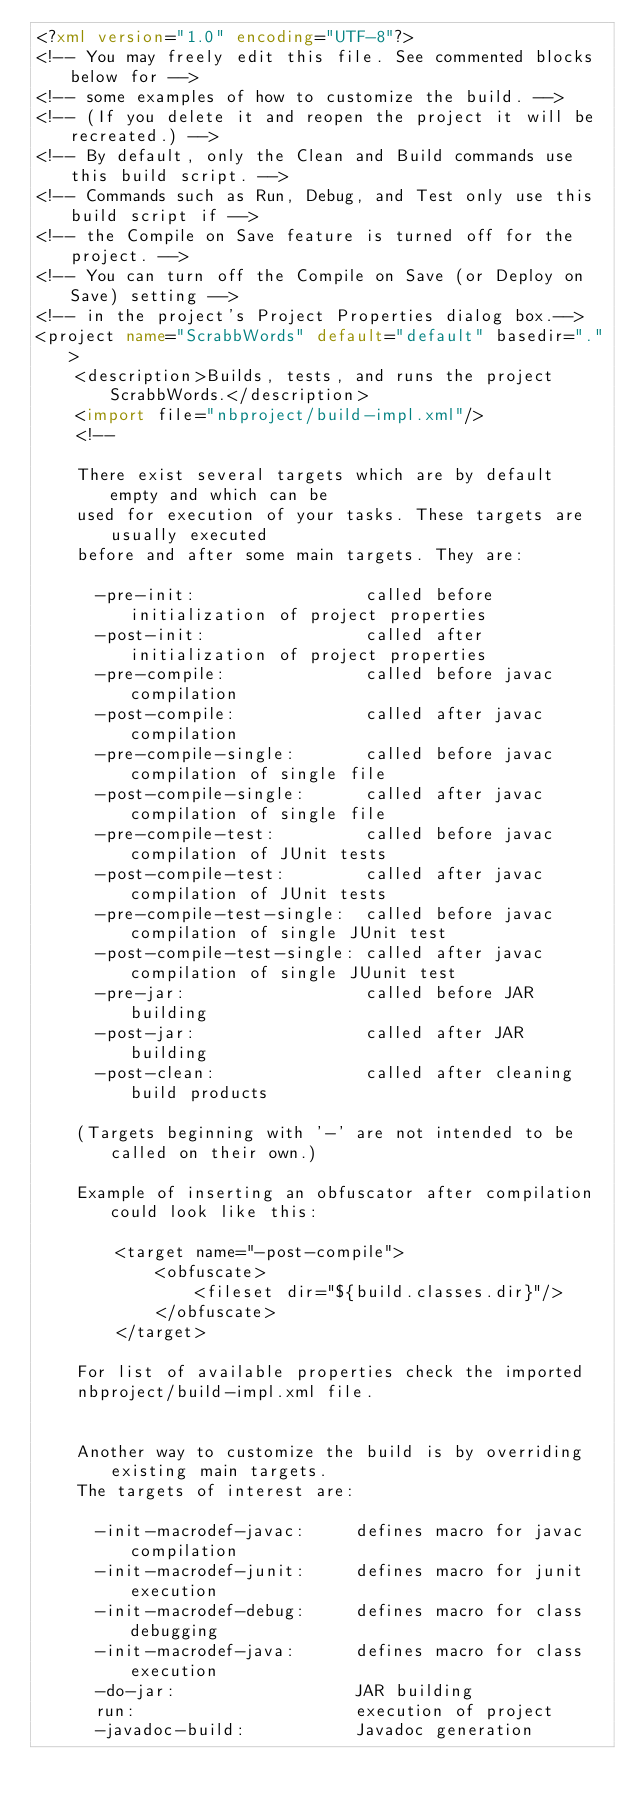Convert code to text. <code><loc_0><loc_0><loc_500><loc_500><_XML_><?xml version="1.0" encoding="UTF-8"?>
<!-- You may freely edit this file. See commented blocks below for -->
<!-- some examples of how to customize the build. -->
<!-- (If you delete it and reopen the project it will be recreated.) -->
<!-- By default, only the Clean and Build commands use this build script. -->
<!-- Commands such as Run, Debug, and Test only use this build script if -->
<!-- the Compile on Save feature is turned off for the project. -->
<!-- You can turn off the Compile on Save (or Deploy on Save) setting -->
<!-- in the project's Project Properties dialog box.-->
<project name="ScrabbWords" default="default" basedir=".">
    <description>Builds, tests, and runs the project ScrabbWords.</description>
    <import file="nbproject/build-impl.xml"/>
    <!--

    There exist several targets which are by default empty and which can be 
    used for execution of your tasks. These targets are usually executed 
    before and after some main targets. They are: 

      -pre-init:                 called before initialization of project properties
      -post-init:                called after initialization of project properties
      -pre-compile:              called before javac compilation
      -post-compile:             called after javac compilation
      -pre-compile-single:       called before javac compilation of single file
      -post-compile-single:      called after javac compilation of single file
      -pre-compile-test:         called before javac compilation of JUnit tests
      -post-compile-test:        called after javac compilation of JUnit tests
      -pre-compile-test-single:  called before javac compilation of single JUnit test
      -post-compile-test-single: called after javac compilation of single JUunit test
      -pre-jar:                  called before JAR building
      -post-jar:                 called after JAR building
      -post-clean:               called after cleaning build products

    (Targets beginning with '-' are not intended to be called on their own.)

    Example of inserting an obfuscator after compilation could look like this:

        <target name="-post-compile">
            <obfuscate>
                <fileset dir="${build.classes.dir}"/>
            </obfuscate>
        </target>

    For list of available properties check the imported 
    nbproject/build-impl.xml file. 


    Another way to customize the build is by overriding existing main targets.
    The targets of interest are: 

      -init-macrodef-javac:     defines macro for javac compilation
      -init-macrodef-junit:     defines macro for junit execution
      -init-macrodef-debug:     defines macro for class debugging
      -init-macrodef-java:      defines macro for class execution
      -do-jar:                  JAR building
      run:                      execution of project 
      -javadoc-build:           Javadoc generation</code> 